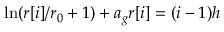Convert formula to latex. <formula><loc_0><loc_0><loc_500><loc_500>\ln ( r [ i ] / r _ { 0 } + 1 ) + a _ { g } r [ i ] = ( i - 1 ) { h }</formula> 